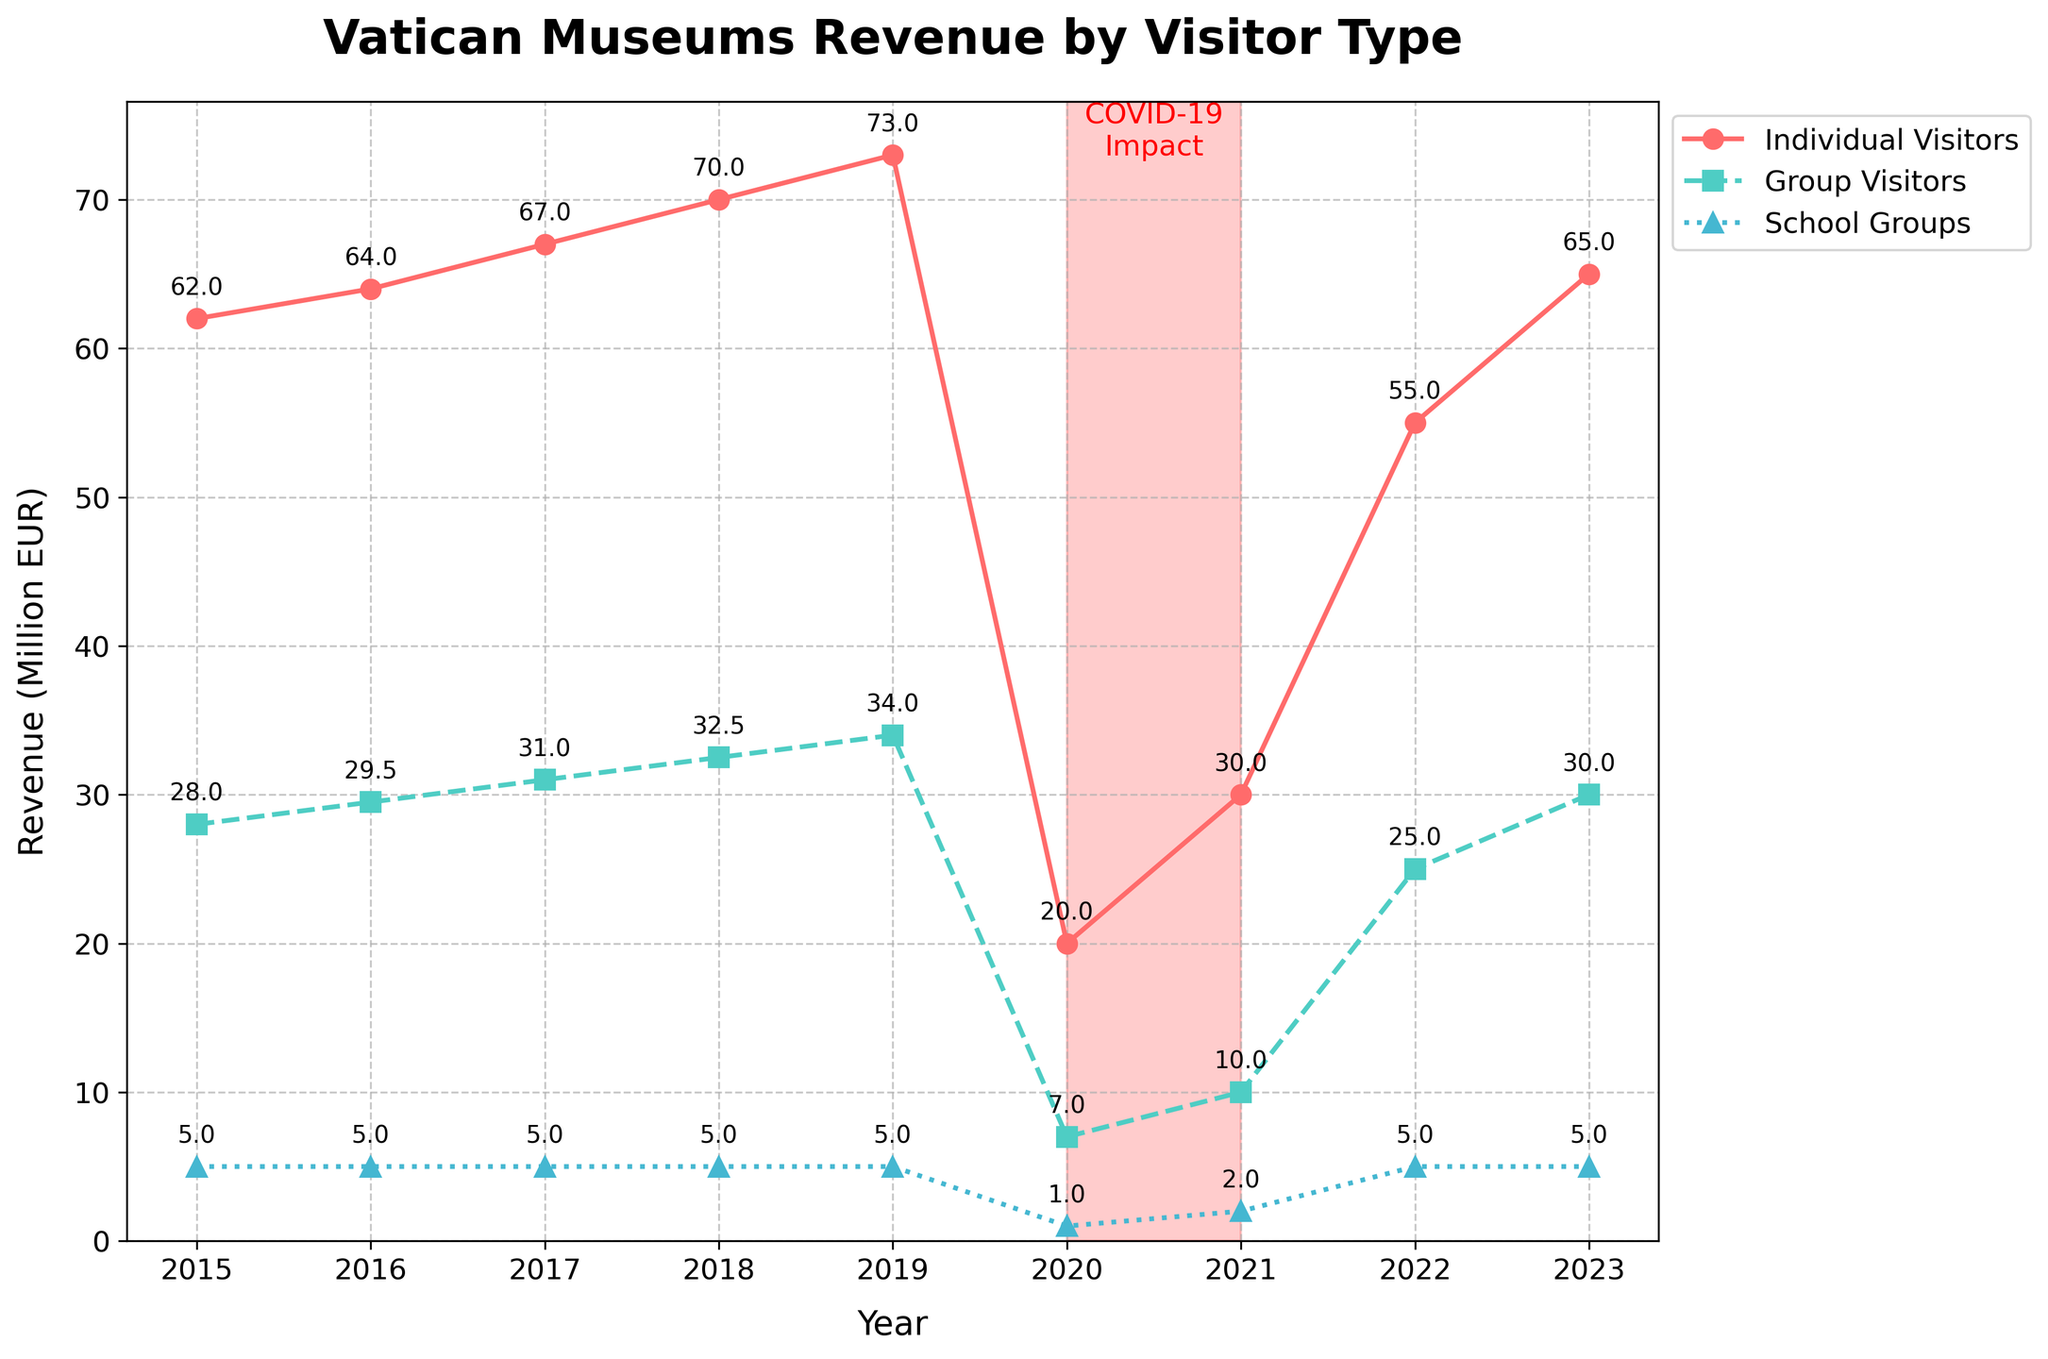How did the revenue from individual visitors change from 2019 to 2020? To find the change, we subtract the revenue in 2020 from the revenue in 2019. Individual visitor revenue in 2019 was 73 million EUR and in 2020 was 20 million EUR. Therefore, the decrease is 73 - 20 = 53 million EUR.
Answer: Decreased by 53 million EUR Which visitor type showed the least change in revenue during the COVID-19 impact years of 2020 and 2021? Looking at the highlighted COVID-19 years, we compare the revenues for individual, group, and school visitors between 2020 and 2021. Individual visitors changed from 20 to 30 million (10 million increase), group visitors from 7 to 10 million (3 million increase), and school groups from 1 to 2 million (1 million increase). The least change is for school groups.
Answer: School groups What is the total revenue from school groups over 2015-2023? We sum the yearly revenues from school groups for all the years provided: 5+5+5+5+5+1+2+5+5 = 38 million EUR.
Answer: 38 million EUR Which year had the highest total revenue and what was the main contributing visitor type? The highest total revenue is 112 million EUR in 2019. Looking at the breakdown, individual visitors contributed the most with 73 million EUR.
Answer: 2019, Individual visitors How did the revenue for group visitors change from 2018 to 2022? We subtract the revenue for group visitors in 2018 (32.5 million EUR) from the revenue in 2022 (25 million EUR), resulting in a decrease. 32.5 - 25 = 7.5 million EUR.
Answer: Decreased by 7.5 million EUR What is the average yearly revenue for individual visitors from 2015 to 2023? To find the average, sum the yearly revenues (62+64+67+70+73+20+30+55+65 = 506 million EUR) and divide by the number of years (9). 506 / 9 = 56.2 million EUR.
Answer: 56.2 million EUR Which visitor type had the least revenue in 2023 and what was that amount? From the chart, school groups had the least revenue in 2023 with 5 million EUR.
Answer: School groups, 5 million EUR Compare the total revenue from group visitors in the pre-COVID years (2015-2019) to the post-COVID years (2020-2023). Sum the group visitor revenues for pre-COVID years (28+29.5+31+32.5+34 = 155 million EUR) and for post-COVID years (7+10+25+30 = 72 million EUR). The post-COVID total is significantly lesser.
Answer: Pre-COVID: 155 million EUR, Post-COVID: 72 million EUR By what percentage did the total revenue decrease from 2019 to 2020? To find the percentage decrease: ((112 - 28) / 112) * 100 = 75%.
Answer: 75% decrease 